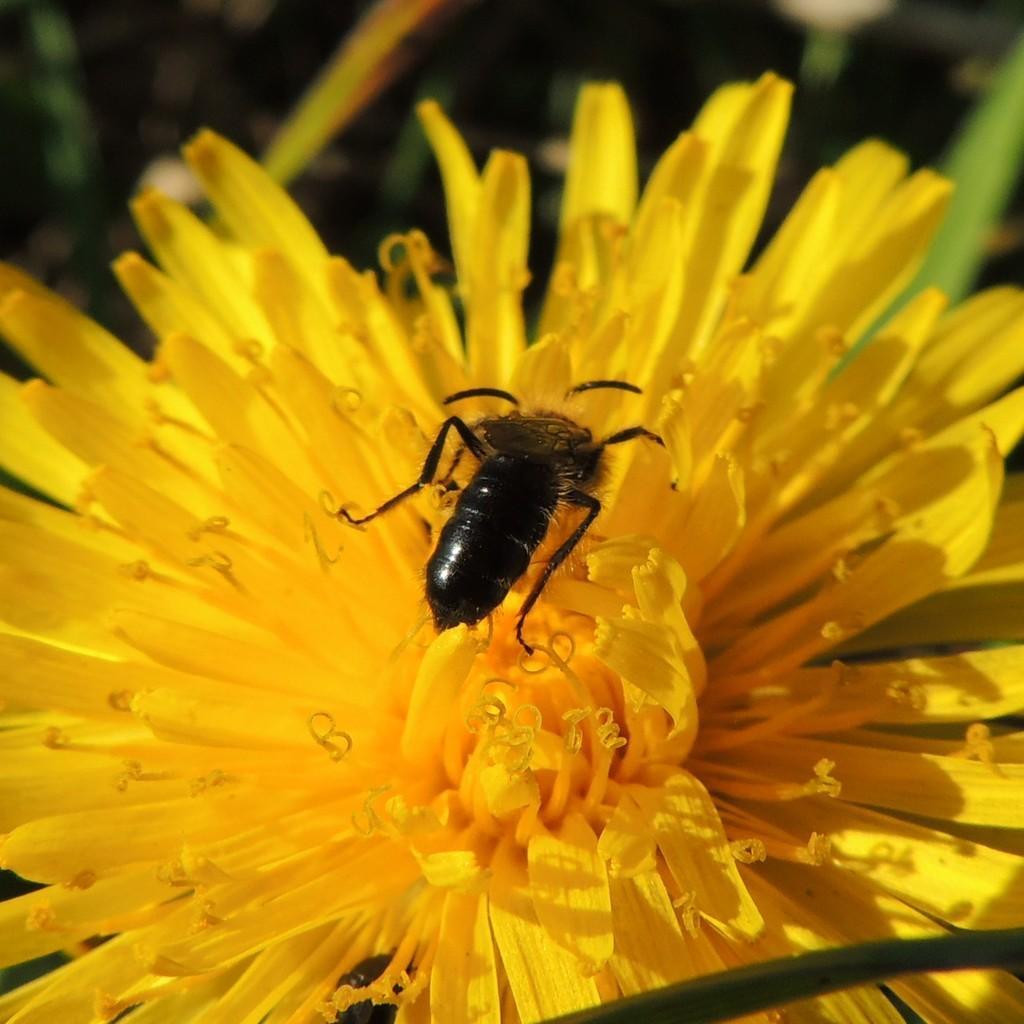Could you give a brief overview of what you see in this image? In the image we can see a flower, on the flower there is a insect. 